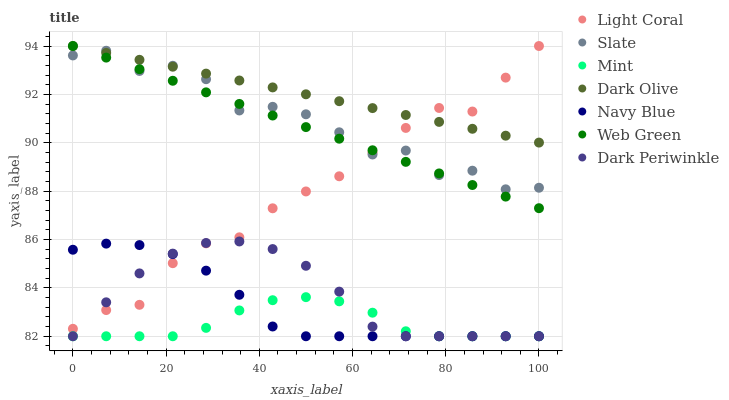Does Mint have the minimum area under the curve?
Answer yes or no. Yes. Does Dark Olive have the maximum area under the curve?
Answer yes or no. Yes. Does Slate have the minimum area under the curve?
Answer yes or no. No. Does Slate have the maximum area under the curve?
Answer yes or no. No. Is Dark Olive the smoothest?
Answer yes or no. Yes. Is Slate the roughest?
Answer yes or no. Yes. Is Slate the smoothest?
Answer yes or no. No. Is Dark Olive the roughest?
Answer yes or no. No. Does Navy Blue have the lowest value?
Answer yes or no. Yes. Does Slate have the lowest value?
Answer yes or no. No. Does Light Coral have the highest value?
Answer yes or no. Yes. Does Slate have the highest value?
Answer yes or no. No. Is Mint less than Dark Olive?
Answer yes or no. Yes. Is Dark Olive greater than Mint?
Answer yes or no. Yes. Does Mint intersect Dark Periwinkle?
Answer yes or no. Yes. Is Mint less than Dark Periwinkle?
Answer yes or no. No. Is Mint greater than Dark Periwinkle?
Answer yes or no. No. Does Mint intersect Dark Olive?
Answer yes or no. No. 